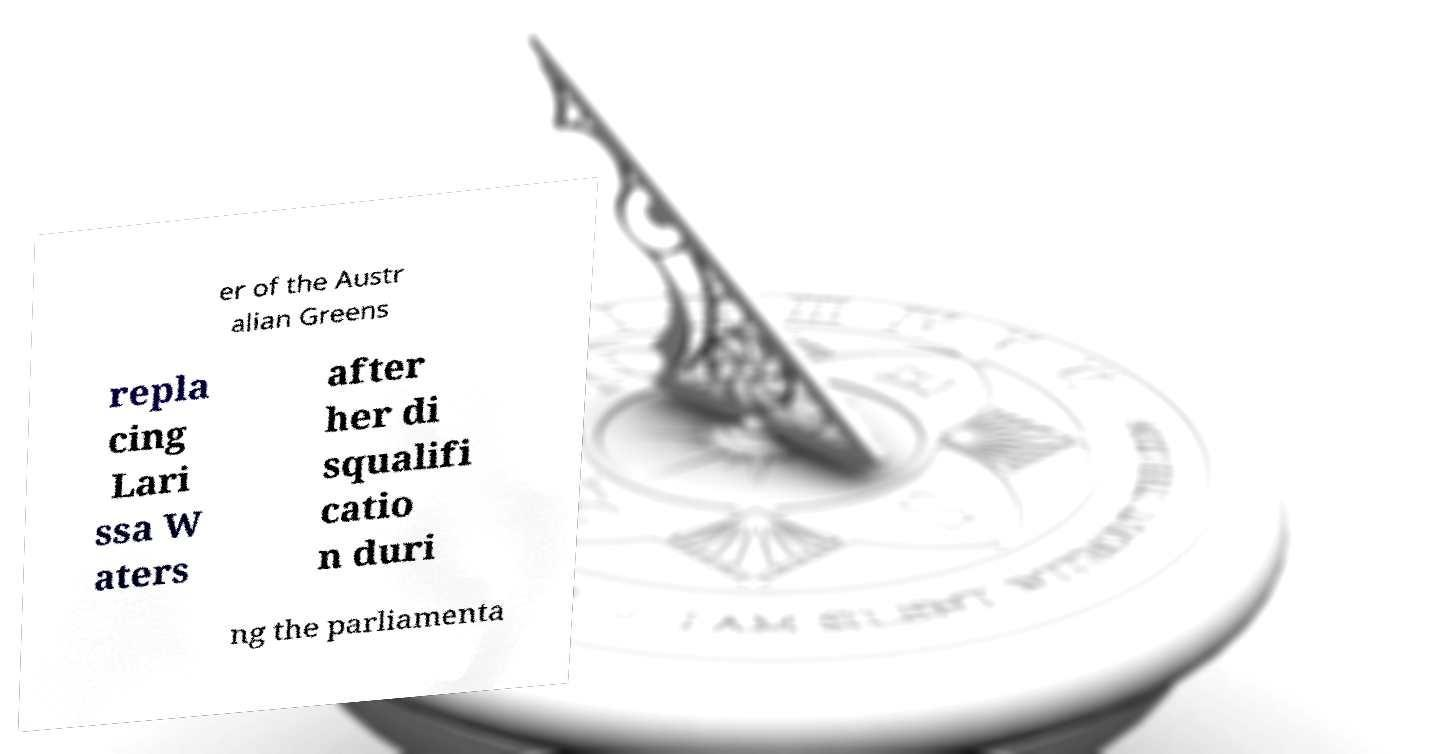Can you read and provide the text displayed in the image?This photo seems to have some interesting text. Can you extract and type it out for me? er of the Austr alian Greens repla cing Lari ssa W aters after her di squalifi catio n duri ng the parliamenta 